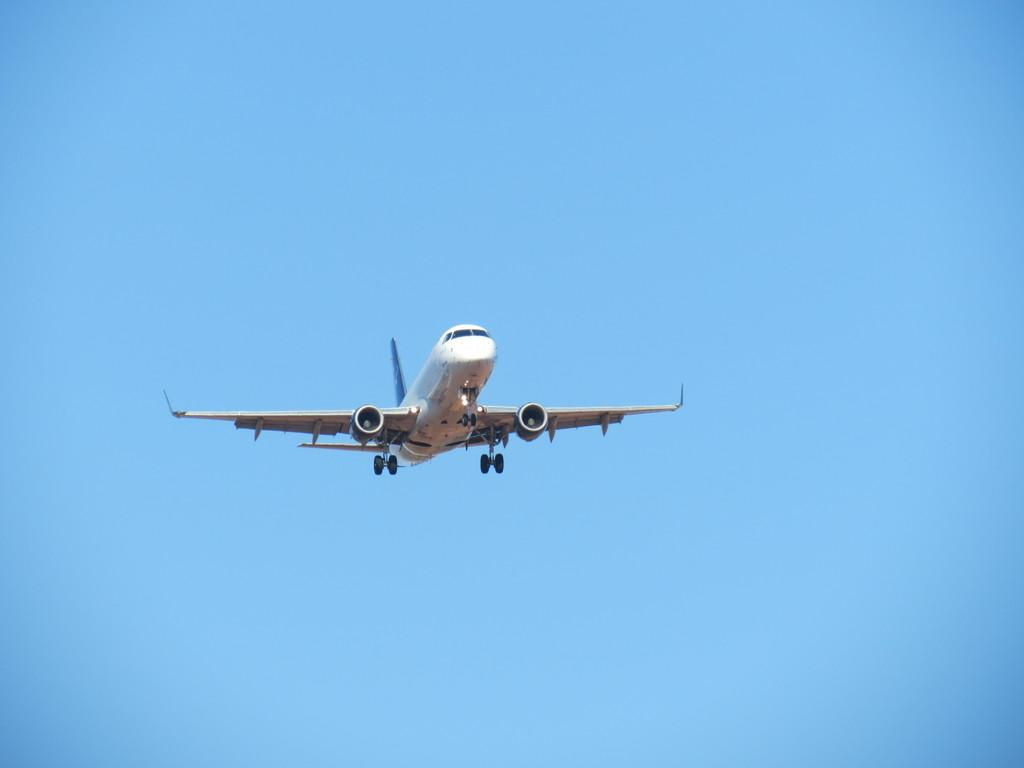What is the main subject of the image? The main subject of the image is a plane. What color is the plane? The plane is white in color. What is the plane doing in the image? The plane is flying in the air. What is the color of the sky in the image? The sky is blue in color. Where is the camp located in the image? There is no camp present in the image; it features a white plane flying in the blue sky. What type of vacation is the plane on in the image? The image does not provide information about the plane's destination or purpose, so it cannot be determined if it is on vacation. 